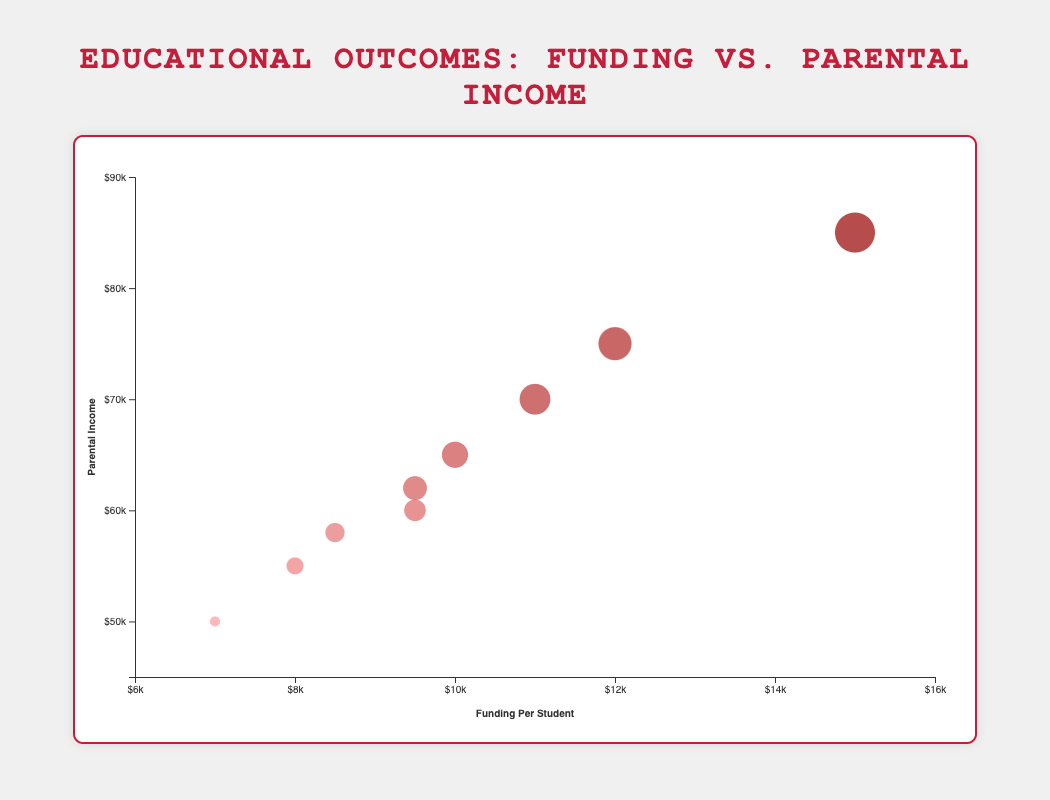How many schools are represented in the chart? Count the number of distinct data points (circles) displayed in the chart.
Answer: 9 Which school has the highest parental income? Identify the circle positioned highest on the y-axis, which represents parental income. The tooltip or label should indicate the name of the school.
Answer: Washington High School What is the range of funding per student among the displayed schools? Find the lowest and highest values on the x-axis, representing funding per student. The range is the difference between these two values.
Answer: $7,000 - $15,000 Which school has the lowest average test score and what is the score? Identify the smallest bubble because the radius of the bubble represents the average test score. The tooltip will provide the specific average test score.
Answer: Hamilton High School, 75 Is there any school with funding per student between $9,000 and $10,000? Look for bubbles positioned between 9,000 and 10,000 on the x-axis, then check their tooltips or labels for detailed information.
Answer: Yes, Roosevelt High School and Jackson High School Which school has a higher graduation rate: Madison High School or Jefferson High School? Identify the bubble colors for both schools and compare them. The graduation rate is indicated by the color, with darker shades representing higher rates. The tooltips can give exact percentages.
Answer: Madison High School What is the average parental income of schools with a graduation rate above 0.90? Identify the schools with a graduation rate above 0.90 (darker colored bubbles), sum their parental incomes, and divide by the number of these schools.
Answer: ($75,000 + $85,000 + $70,000) / 3 = $76,667 How does the average test score of Franklin High School compare to that of Lincoln High School? Compare the sizes of the bubbles representing these schools since the bubble size denotes the average test score. The tooltip provides exact scores.
Answer: 78 vs. 85; Lincoln High School has a higher average test score Are schools with higher funding per student generally associated with higher graduation rates based on the chart? Observe the general trend in bubble colors as one scans from left to right (lower to higher funding per student) and see if the colors get darker (indicating higher graduation rates). A more detailed look at individual cases may be necessary for a precise answer.
Answer: Generally, yes What is the correlation between parental income and average test score? Identify general trends by observing vertical positions (parental income) and bubble sizes (average test score). Look for a discernible pattern where higher parental income aligns with larger bubbles.
Answer: Positive correlation 